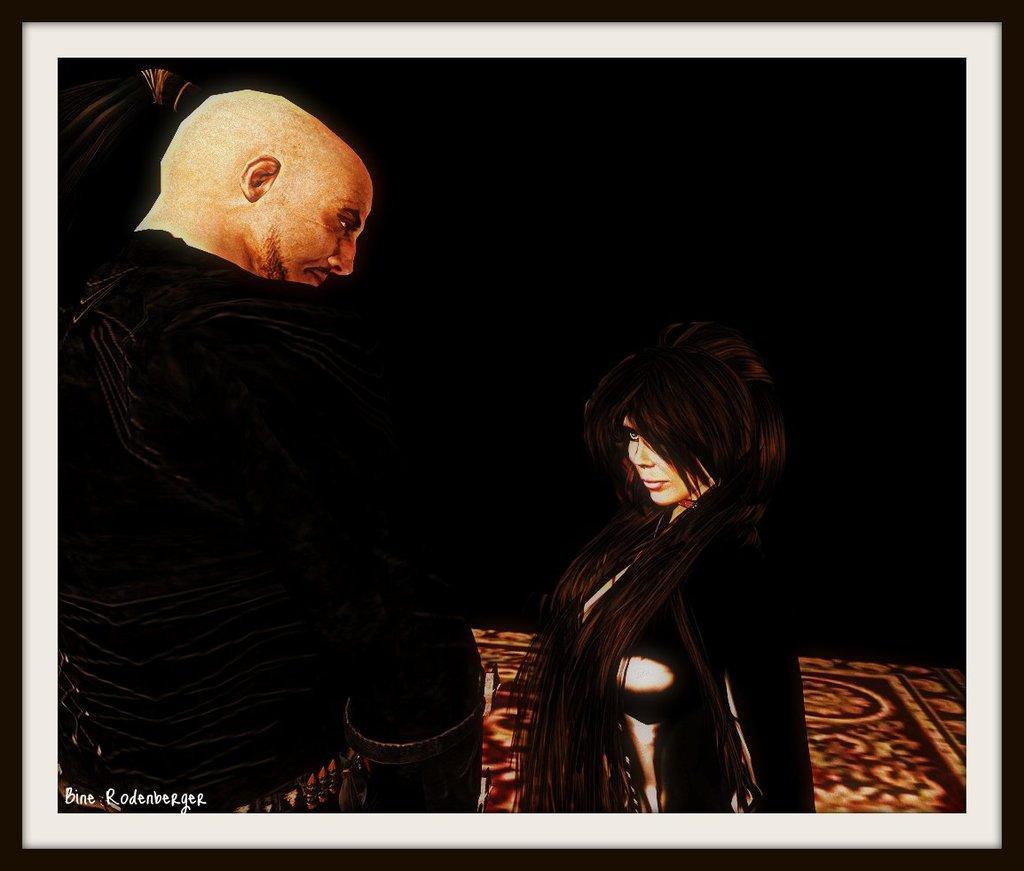In one or two sentences, can you explain what this image depicts? In this image we can see a photo frame. In the photo we can see two persons. The background of the image is dark. In the bottom left we can see some text. 